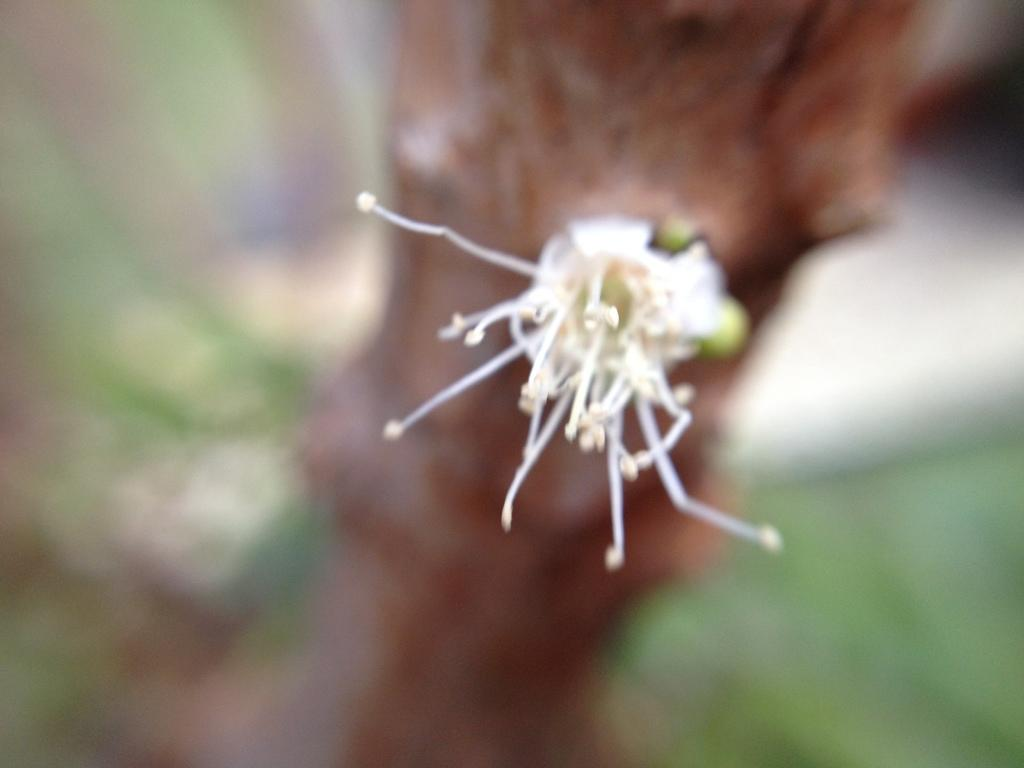What is the main subject of the picture? The main subject of the picture is flower buds. Where are the flower buds located in the image? The flower buds are in the middle of the picture. Can you describe the background of the image? The background of the image is blurred. What type of mark can be seen on the monkey's forehead in the image? There is no monkey present in the image, so it is not possible to determine if there is a mark on its forehead. 